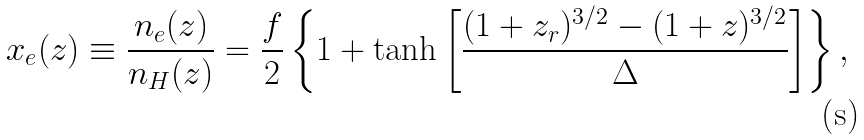<formula> <loc_0><loc_0><loc_500><loc_500>x _ { e } ( z ) \equiv \frac { n _ { e } ( z ) } { n _ { H } ( z ) } = \frac { f } 2 \left \{ 1 + \tanh \left [ \frac { ( 1 + z _ { r } ) ^ { 3 / 2 } - ( 1 + z ) ^ { 3 / 2 } } { \Delta } \right ] \right \} ,</formula> 